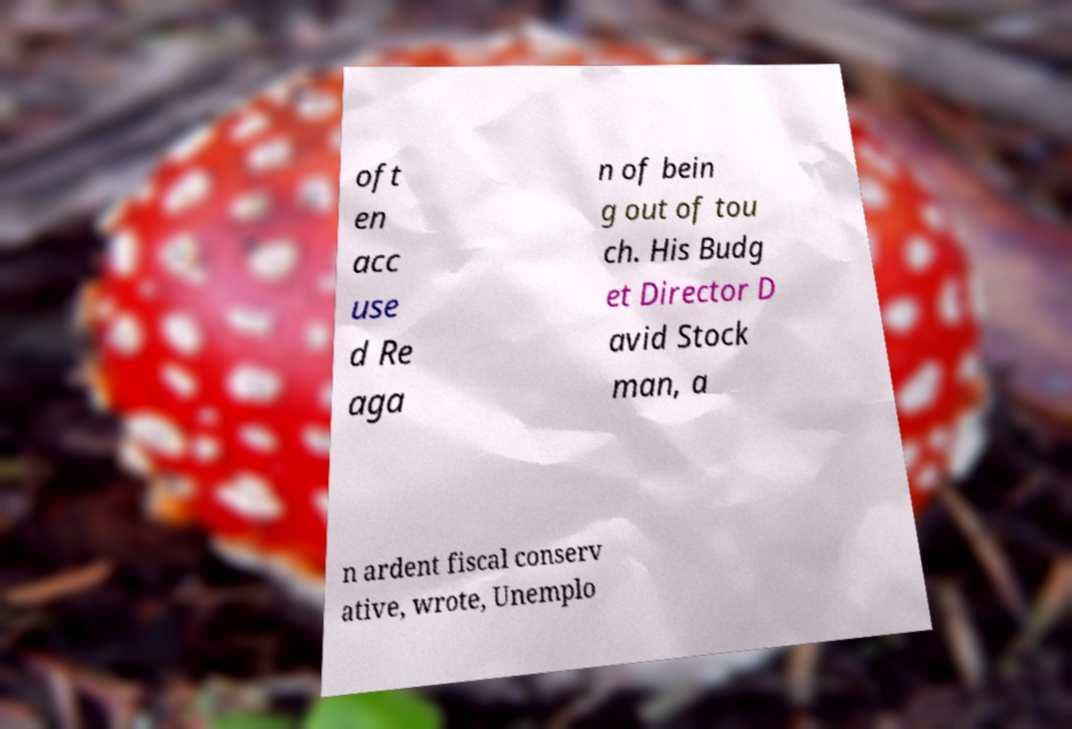Could you extract and type out the text from this image? oft en acc use d Re aga n of bein g out of tou ch. His Budg et Director D avid Stock man, a n ardent fiscal conserv ative, wrote, Unemplo 